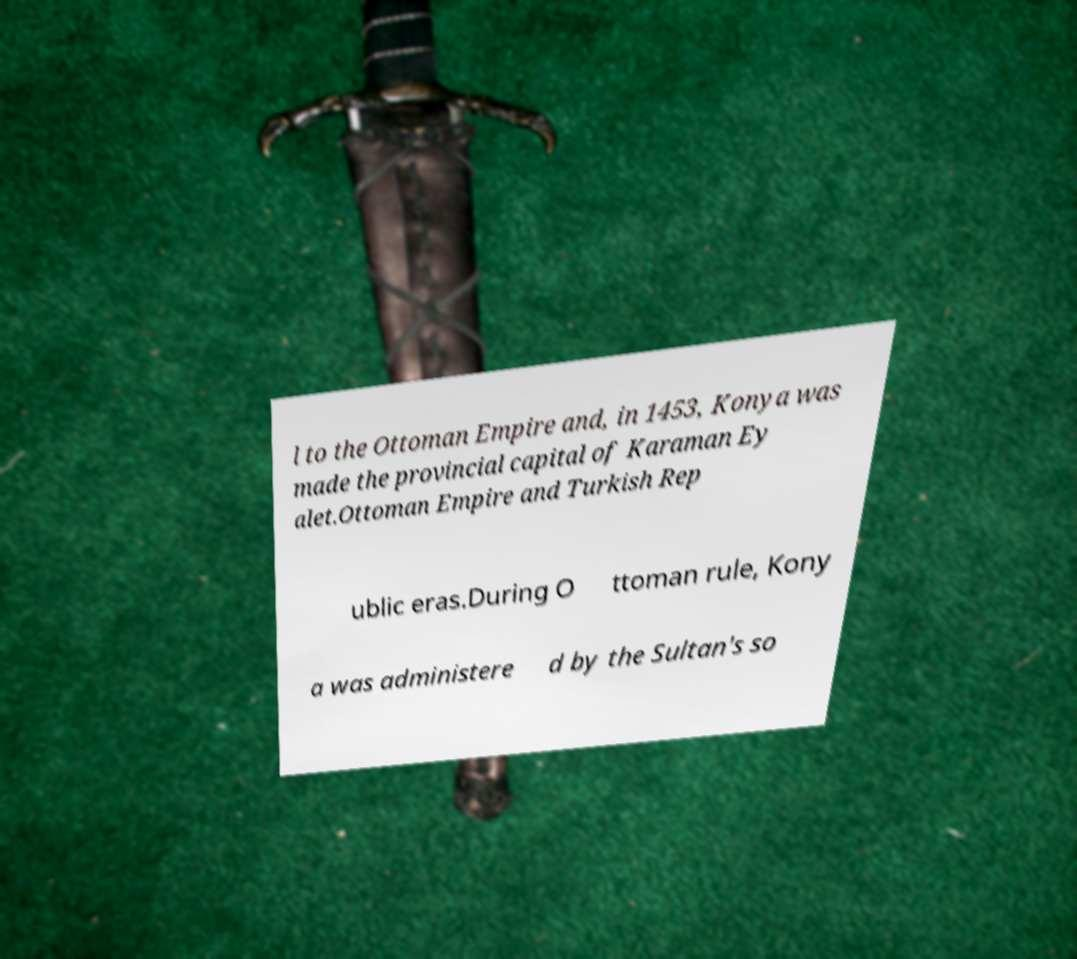Could you extract and type out the text from this image? l to the Ottoman Empire and, in 1453, Konya was made the provincial capital of Karaman Ey alet.Ottoman Empire and Turkish Rep ublic eras.During O ttoman rule, Kony a was administere d by the Sultan's so 